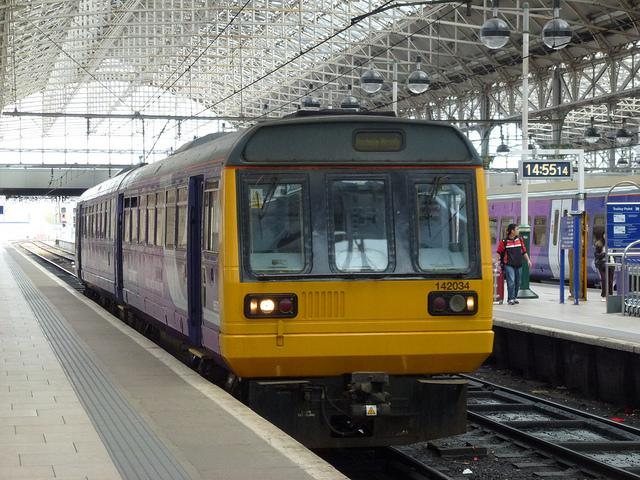What session of the day is shown in the photo? Please explain your reasoning. afternoon. The clock on the platform says the time is 14:55. 